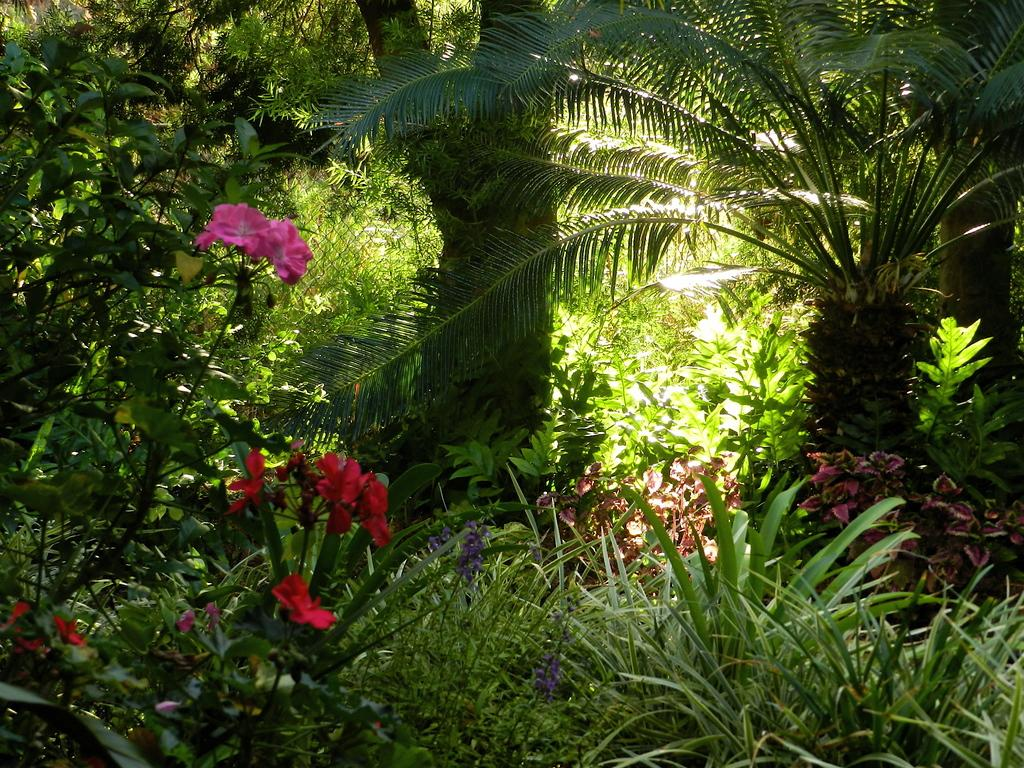What type of vegetation is in the front of the image? There are flowers in the front of the image. What other types of vegetation can be seen in the image? There are plants visible in the image. What can be seen in the background of the image? There are trees in the background of the image. What type of chalk is being used to draw on the trees in the image? There is no chalk or drawing activity present in the image; it features flowers, plants, and trees. 